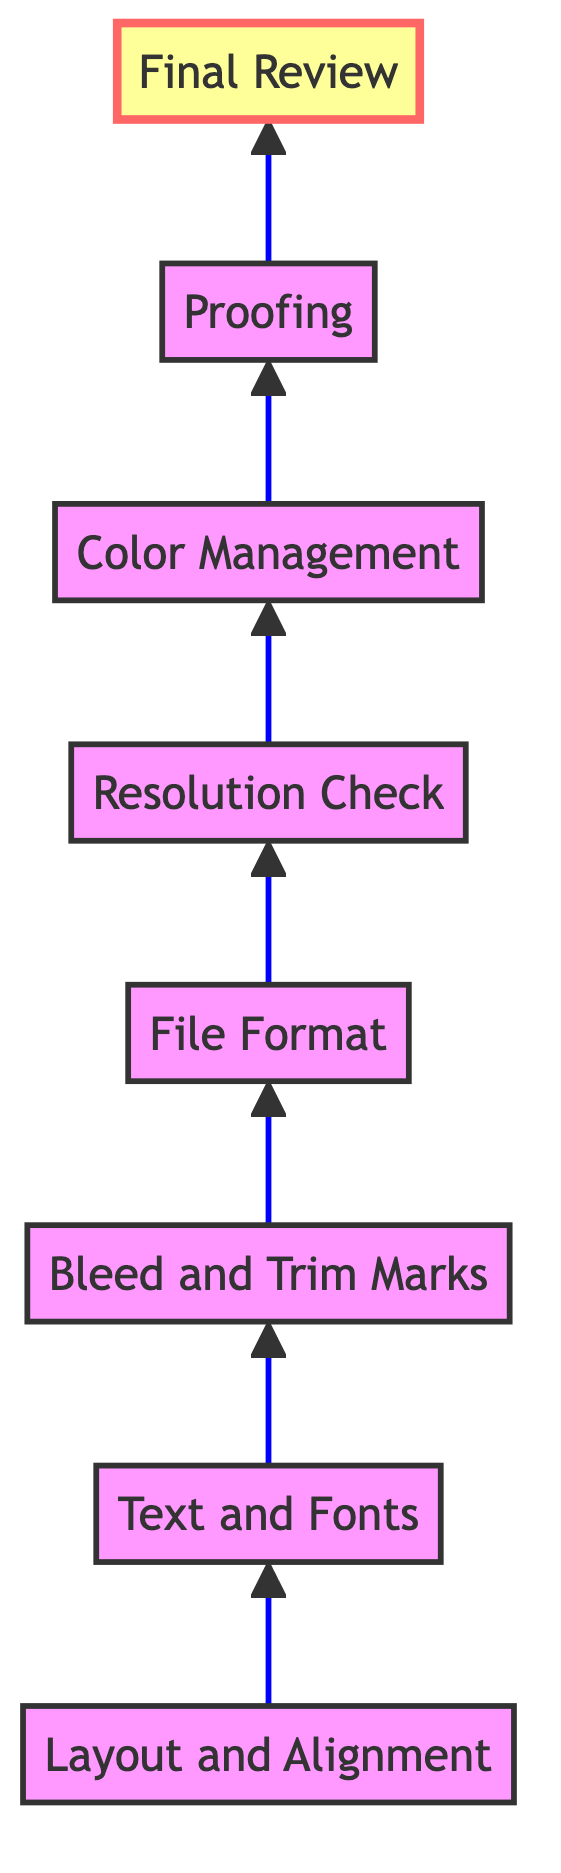What is the first step in the flow chart? The first step in the flow chart is "Layout and Alignment," which is the starting point before proceeding to other steps in preparing digital artwork for print publication.
Answer: Layout and Alignment How many total nodes are in the diagram? There are eight total nodes in the diagram, including all the steps involved in preparing the digital artwork for print publication.
Answer: 8 Which step comes after "Text and Fonts"? "Bleed and Trim Marks" comes immediately after "Text and Fonts," indicating the sequence in the process for preparing digital artwork.
Answer: Bleed and Trim Marks What is the final step in the flow chart? The final step in the flow chart is "Final Review," which is the last action taken before publication, ensuring everything is correct.
Answer: Final Review How many steps are between "Resolution Check" and "Proofing"? There is one step between "Resolution Check" and "Proofing," which is "Color Management," indicating the flow from checking resolution to managing color before proofing.
Answer: 1 Which step is directly before "Color Management"? The step directly before "Color Management" is "Resolution Check," showing the necessary checks of image quality before managing color settings.
Answer: Resolution Check What is the relationship between "Proofing" and "Final Review"? "Proofing" is a prerequisite to "Final Review," as it must be completed before the final review of the artwork takes place.
Answer: Prerequisite Which step requires converting colors to CMYK? The step that requires converting colors to CMYK is "Color Management," where adjustments are made to ensure print quality color profiles.
Answer: Color Management 